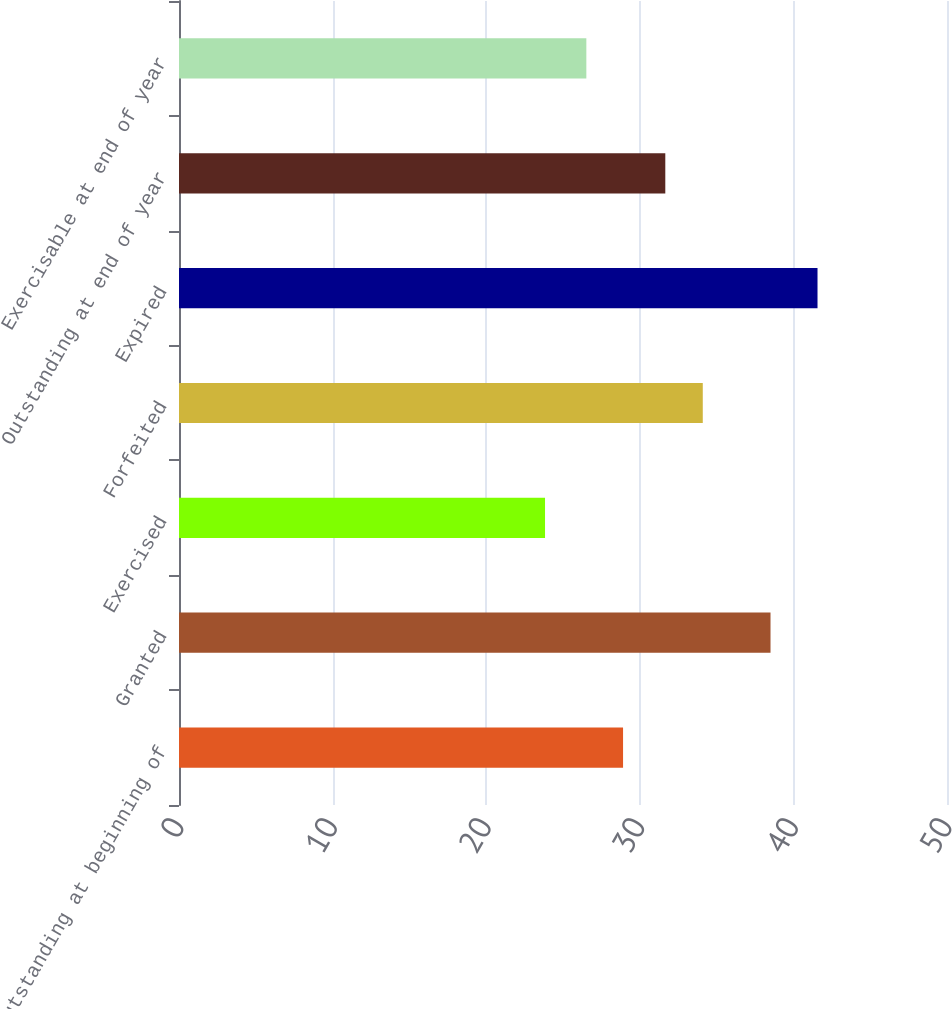<chart> <loc_0><loc_0><loc_500><loc_500><bar_chart><fcel>Outstanding at beginning of<fcel>Granted<fcel>Exercised<fcel>Forfeited<fcel>Expired<fcel>Outstanding at end of year<fcel>Exercisable at end of year<nl><fcel>28.91<fcel>38.51<fcel>23.83<fcel>34.1<fcel>41.57<fcel>31.66<fcel>26.52<nl></chart> 